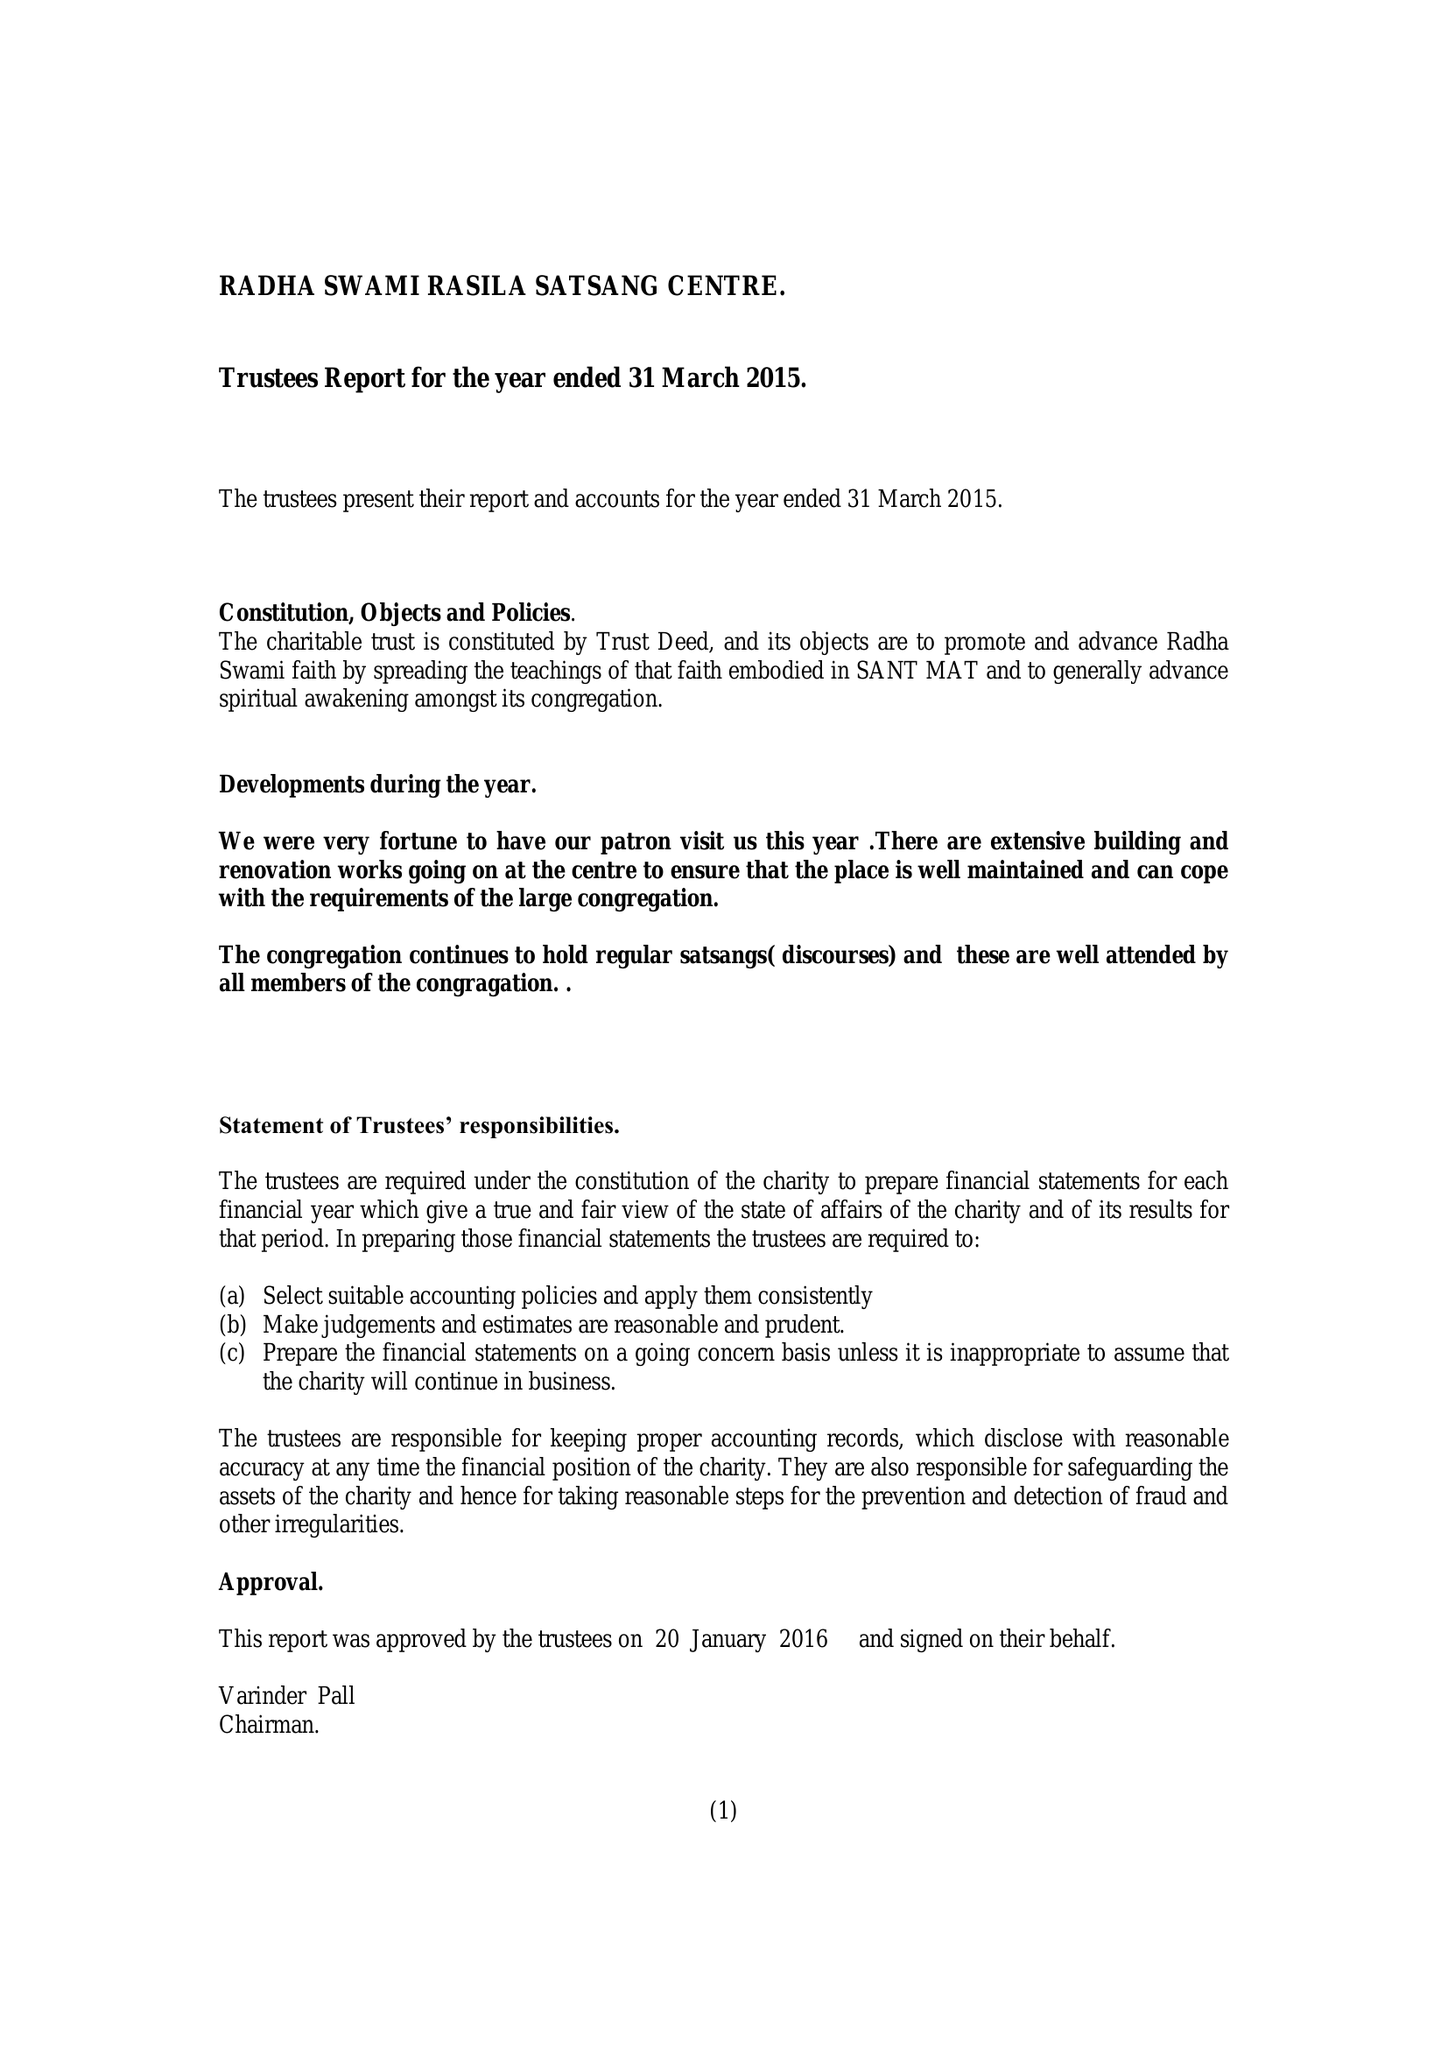What is the value for the address__post_town?
Answer the question using a single word or phrase. BIRMINGHAM 